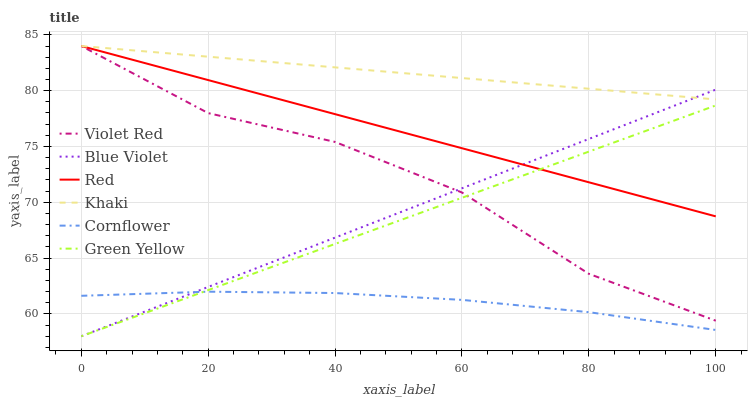Does Violet Red have the minimum area under the curve?
Answer yes or no. No. Does Violet Red have the maximum area under the curve?
Answer yes or no. No. Is Violet Red the smoothest?
Answer yes or no. No. Is Khaki the roughest?
Answer yes or no. No. Does Violet Red have the lowest value?
Answer yes or no. No. Does Blue Violet have the highest value?
Answer yes or no. No. Is Green Yellow less than Khaki?
Answer yes or no. Yes. Is Khaki greater than Cornflower?
Answer yes or no. Yes. Does Green Yellow intersect Khaki?
Answer yes or no. No. 